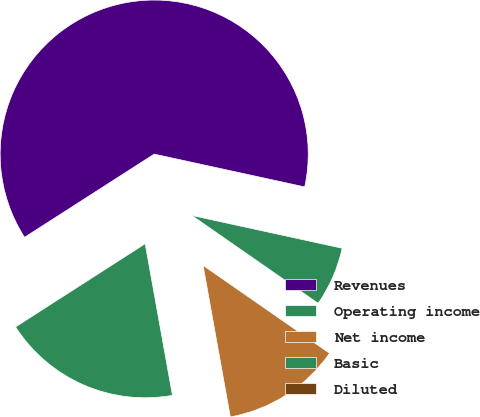Convert chart. <chart><loc_0><loc_0><loc_500><loc_500><pie_chart><fcel>Revenues<fcel>Operating income<fcel>Net income<fcel>Basic<fcel>Diluted<nl><fcel>62.5%<fcel>18.75%<fcel>12.5%<fcel>6.25%<fcel>0.0%<nl></chart> 